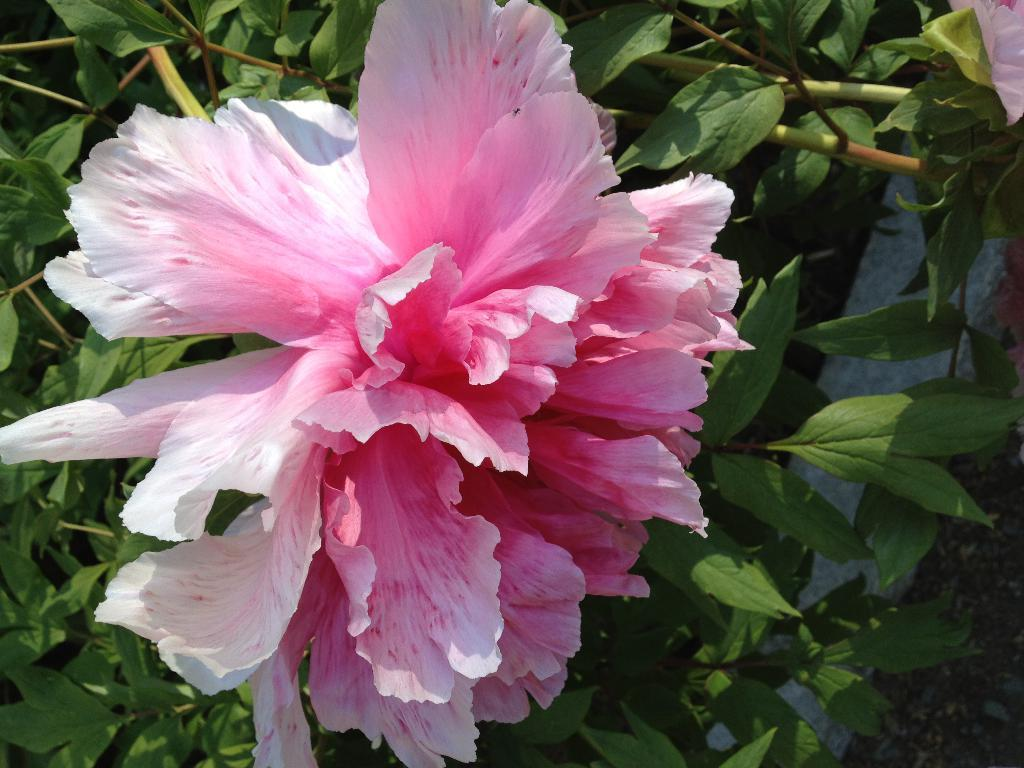What type of plant material is present in the image? There are green leaves and stems in the image. What type of plant is featured in the image? There is a flower in the image. Where is a flower petal located in the image? A flower petal is visible in the top right corner of the image. What type of calendar is hanging on the wall in the image? There is no calendar present in the image; it features plant materials such as leaves, stems, and a flower. Who is the writer of the book seen on the table in the image? There is no book or writer present in the image; it focuses on plant materials. 